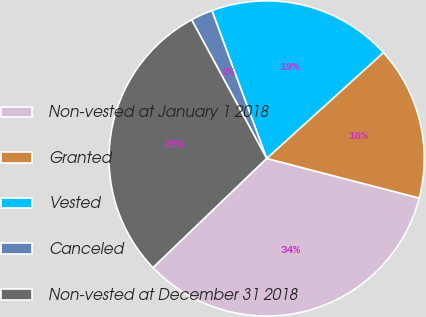<chart> <loc_0><loc_0><loc_500><loc_500><pie_chart><fcel>Non-vested at January 1 2018<fcel>Granted<fcel>Vested<fcel>Canceled<fcel>Non-vested at December 31 2018<nl><fcel>33.78%<fcel>15.77%<fcel>18.92%<fcel>2.25%<fcel>29.28%<nl></chart> 